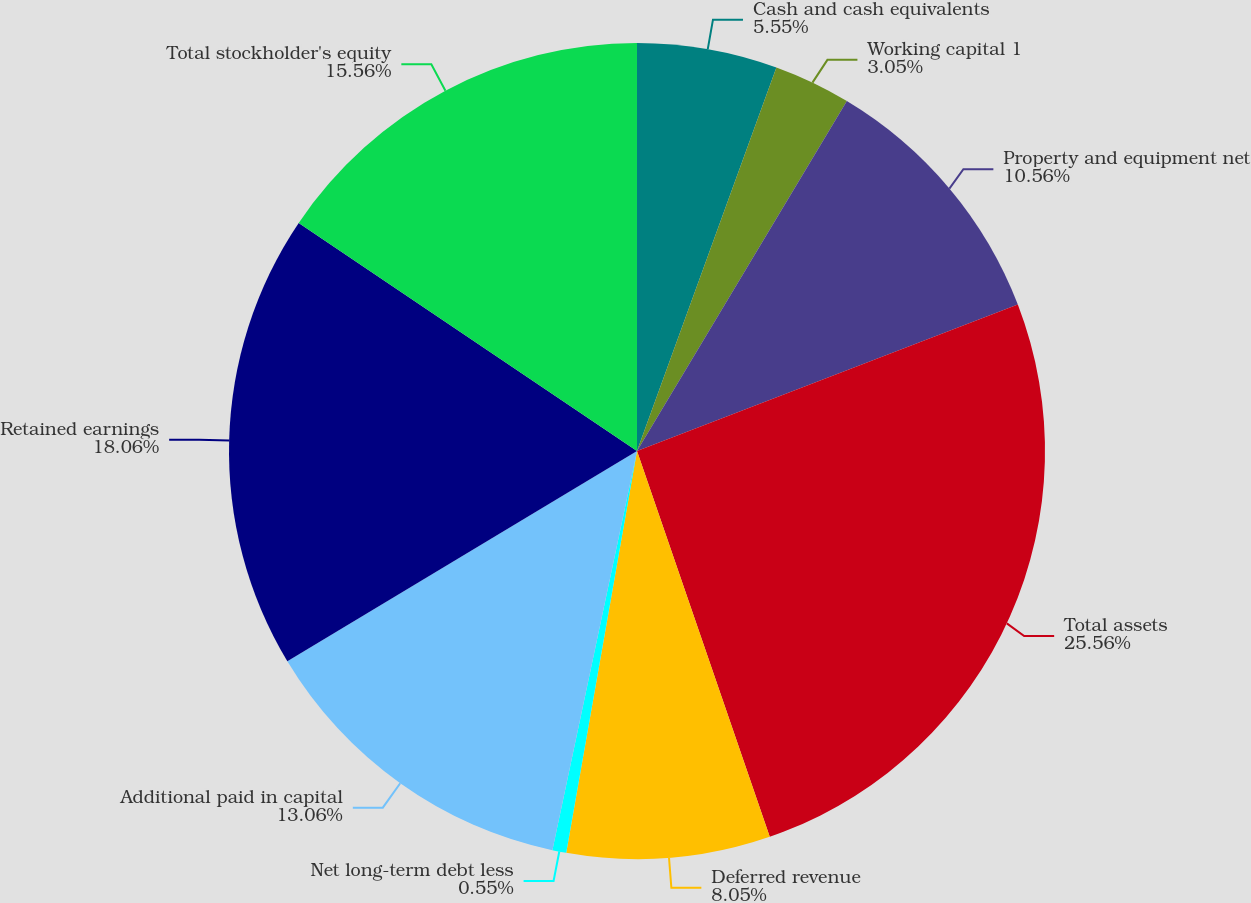Convert chart to OTSL. <chart><loc_0><loc_0><loc_500><loc_500><pie_chart><fcel>Cash and cash equivalents<fcel>Working capital 1<fcel>Property and equipment net<fcel>Total assets<fcel>Deferred revenue<fcel>Net long-term debt less<fcel>Additional paid in capital<fcel>Retained earnings<fcel>Total stockholder's equity<nl><fcel>5.55%<fcel>3.05%<fcel>10.56%<fcel>25.57%<fcel>8.05%<fcel>0.55%<fcel>13.06%<fcel>18.06%<fcel>15.56%<nl></chart> 